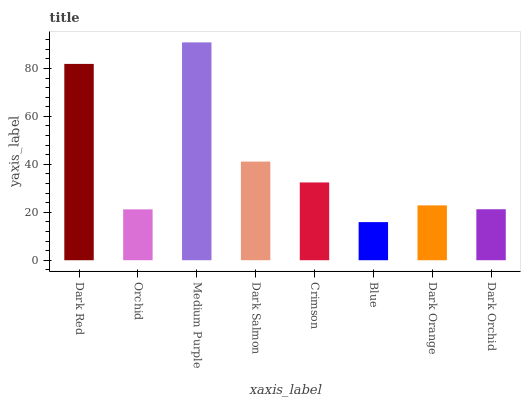Is Blue the minimum?
Answer yes or no. Yes. Is Medium Purple the maximum?
Answer yes or no. Yes. Is Orchid the minimum?
Answer yes or no. No. Is Orchid the maximum?
Answer yes or no. No. Is Dark Red greater than Orchid?
Answer yes or no. Yes. Is Orchid less than Dark Red?
Answer yes or no. Yes. Is Orchid greater than Dark Red?
Answer yes or no. No. Is Dark Red less than Orchid?
Answer yes or no. No. Is Crimson the high median?
Answer yes or no. Yes. Is Dark Orange the low median?
Answer yes or no. Yes. Is Blue the high median?
Answer yes or no. No. Is Dark Orchid the low median?
Answer yes or no. No. 